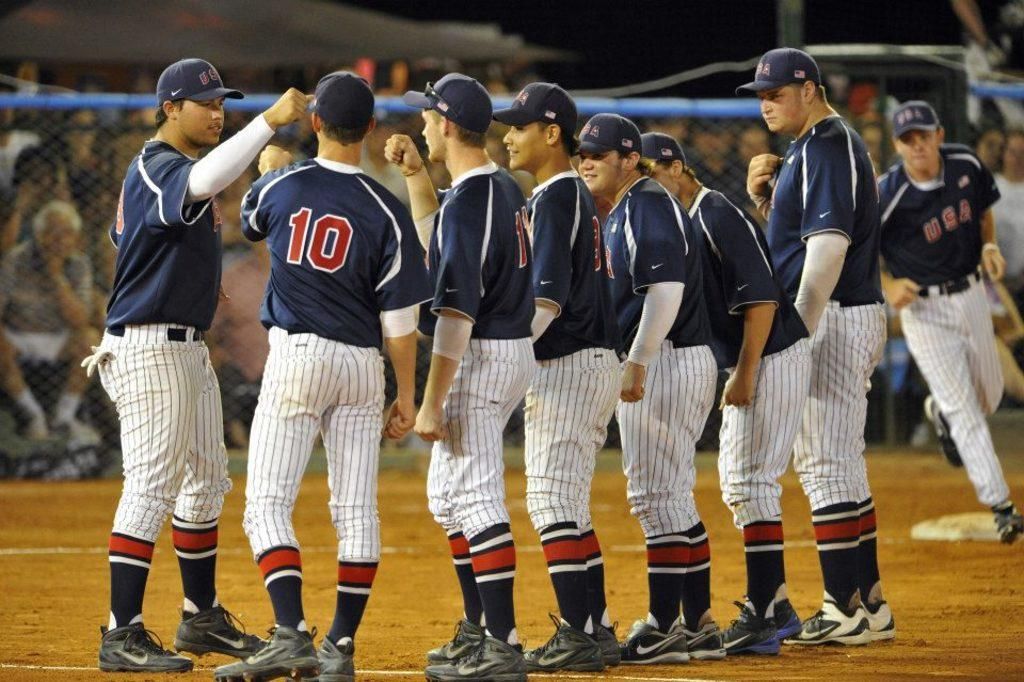<image>
Offer a succinct explanation of the picture presented. A baseball player is standing with the team and has the number 10 on the back of his jersey. 